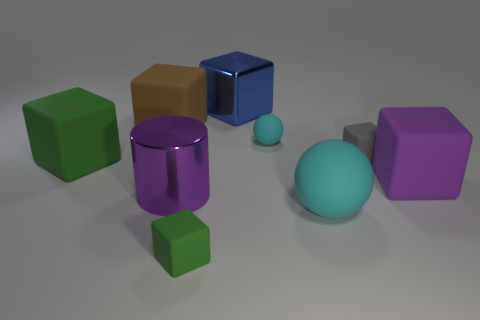How many tiny objects have the same shape as the large green rubber object? There are three tiny objects that have the same cube shape as the large green rubber object. 